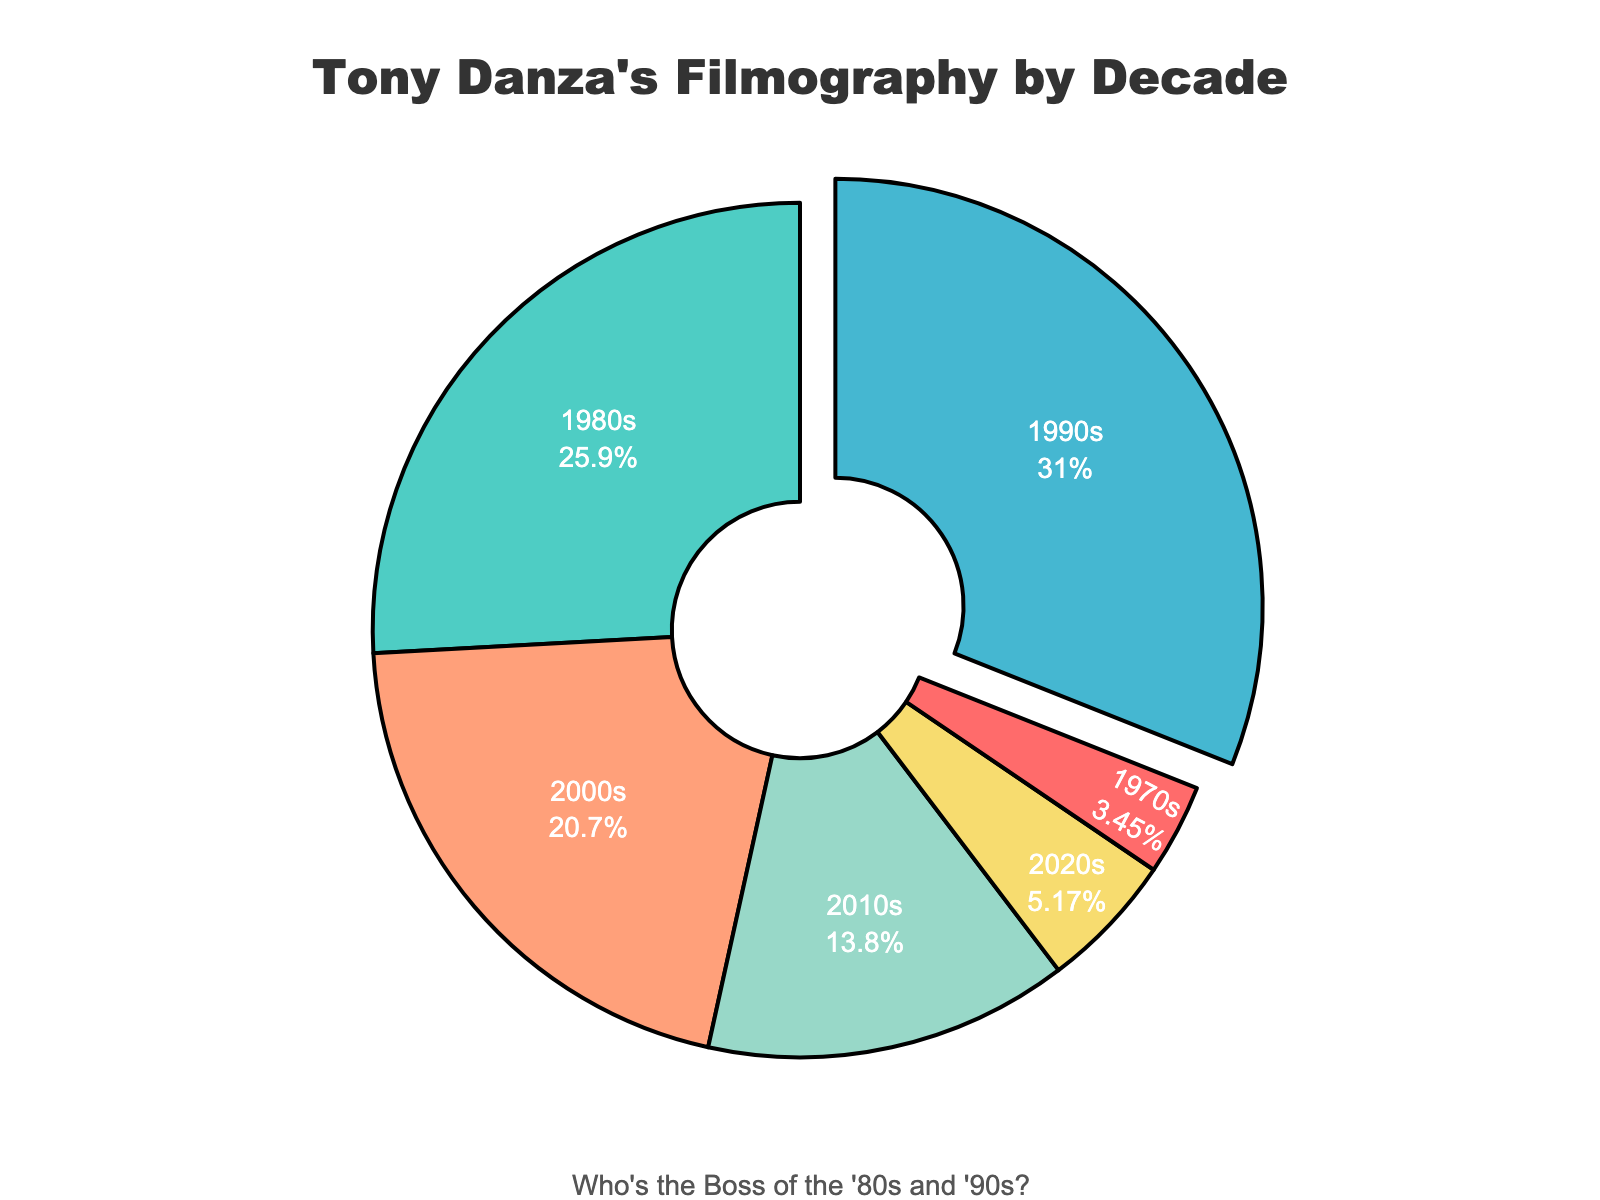What percentage of Tony Danza's projects were in the 1990s? To determine the percentage, first identify the number of projects in the 1990s, which is 18. The total number of projects is 2+15+18+12+8+3 = 58. The percentage for the 1990s is (18/58) * 100 = 31.03%.
Answer: 31.03% Which decade had the most projects? The pie chart shows that the 1990s slice is slightly pulled out, indicating it has the highest number of projects among all decades.
Answer: 1990s Did Tony Danza have more projects in the 1980s or the 2000s? The pie chart shows counts of 15 projects in the 1980s and 12 projects in the 2000s. Comparatively, the 1980s slice is larger than the 2000s slice.
Answer: 1980s What is the difference between the number of projects in the 1980s and the 2010s? The chart indicates 15 projects in the 1980s and 8 in the 2010s. The difference is calculated as 15 - 8 = 7.
Answer: 7 What is the sum of projects from the 2010s and 2020s? The pie chart shows that the projects in the 2010s are 8 and in the 2020s are 3. Adding these together, 8 + 3 = 11.
Answer: 11 What color represents the 1970s in the pie chart? By matching the slices to their corresponding labels and colors, the chart shows that the 1970s are represented by the red slice.
Answer: Red Is the number of projects in the 2000s greater than in the 1970s? The chart counts 12 projects in the 2000s and 2 projects in the 1970s. Therefore, 12 is greater than 2.
Answer: Yes What decade forms the second-largest slice of the pie? The second-largest slice visually is the decade with 15 projects, which is the 1980s.
Answer: 1980s How many projects did Tony Danza complete in the 2000s and 2010s combined? The chart counts 12 projects in the 2000s and 8 in the 2010s. Combined, this is 12 + 8 = 20.
Answer: 20 Did Tony Danza have any decades with fewer than 5 projects? Referring to the pie chart, the slices corresponding to the 1970s and 2020s show 2 and 3 projects, respectively, both of which are fewer than 5.
Answer: Yes 